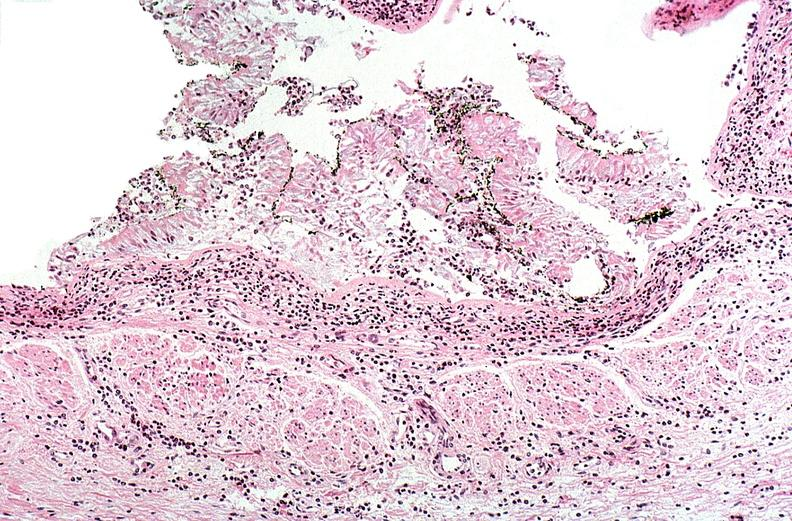s gram present?
Answer the question using a single word or phrase. No 